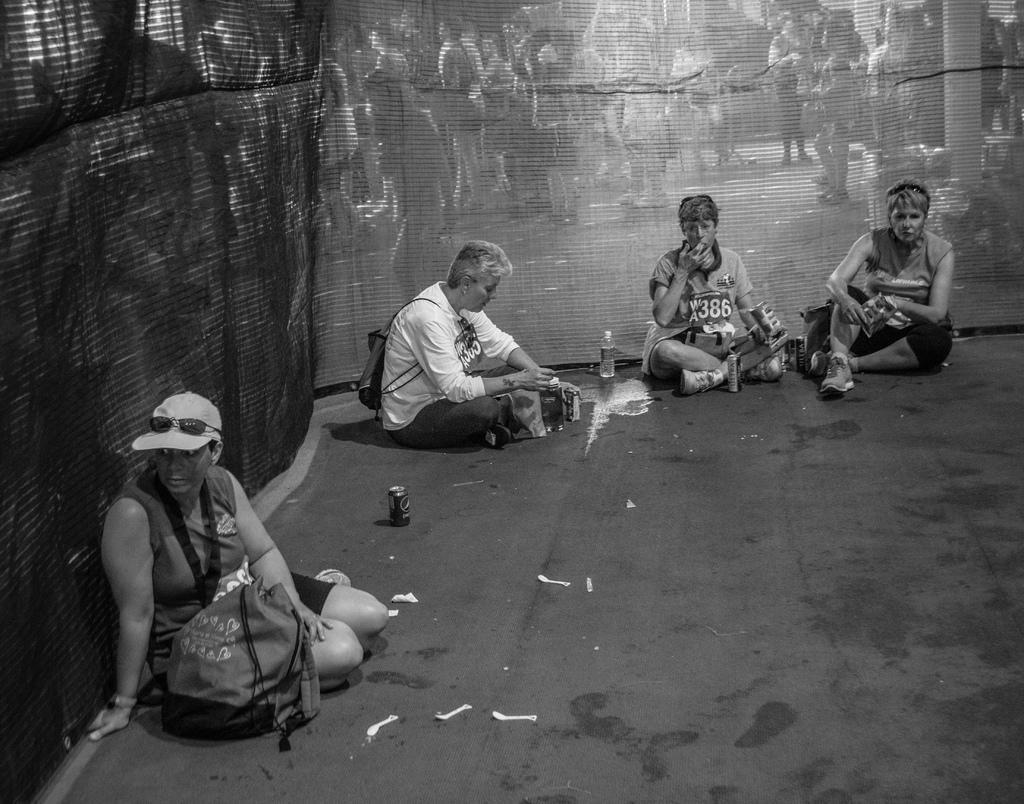How would you summarize this image in a sentence or two? In this picture I see 4 persons who are sitting in front and I see few things beside them and in the background I see number of people and I see that this is a black and white image. 